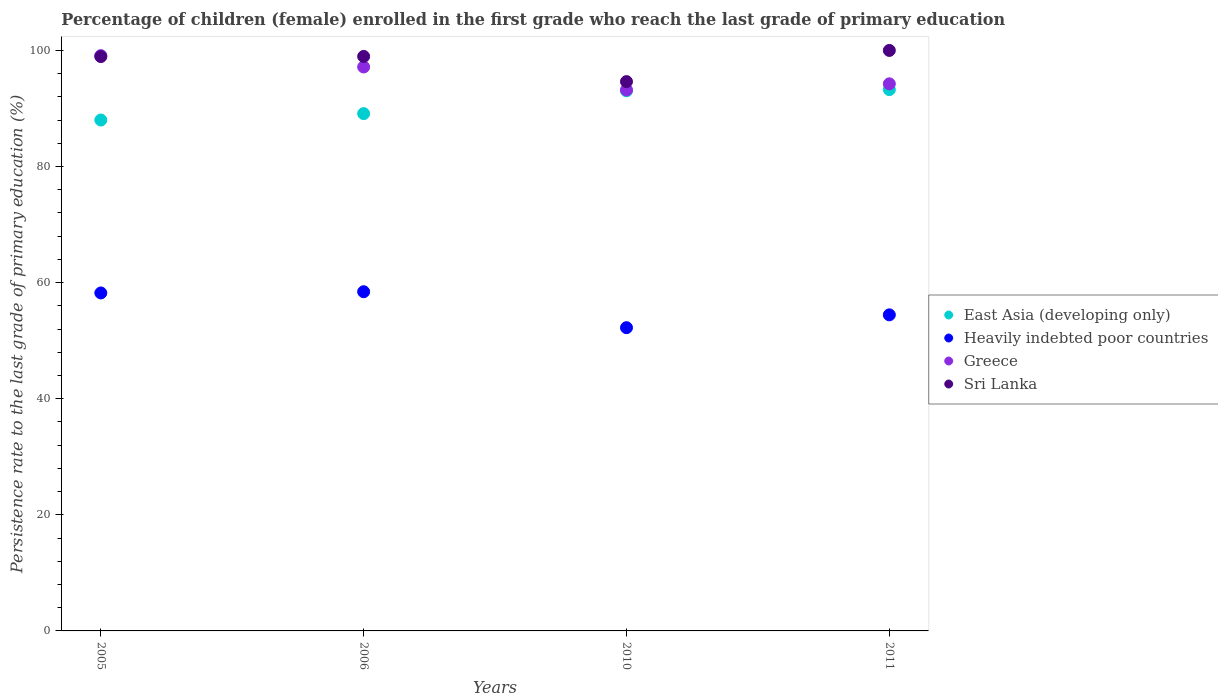Is the number of dotlines equal to the number of legend labels?
Provide a succinct answer. Yes. What is the persistence rate of children in Greece in 2005?
Ensure brevity in your answer.  99.1. Across all years, what is the maximum persistence rate of children in East Asia (developing only)?
Provide a succinct answer. 93.26. Across all years, what is the minimum persistence rate of children in Heavily indebted poor countries?
Your answer should be very brief. 52.24. In which year was the persistence rate of children in East Asia (developing only) minimum?
Provide a short and direct response. 2005. What is the total persistence rate of children in Sri Lanka in the graph?
Keep it short and to the point. 392.54. What is the difference between the persistence rate of children in Heavily indebted poor countries in 2005 and that in 2010?
Ensure brevity in your answer.  5.98. What is the difference between the persistence rate of children in Sri Lanka in 2006 and the persistence rate of children in Greece in 2005?
Offer a very short reply. -0.14. What is the average persistence rate of children in East Asia (developing only) per year?
Offer a very short reply. 90.86. In the year 2006, what is the difference between the persistence rate of children in East Asia (developing only) and persistence rate of children in Greece?
Offer a terse response. -8.04. What is the ratio of the persistence rate of children in Sri Lanka in 2010 to that in 2011?
Make the answer very short. 0.95. What is the difference between the highest and the second highest persistence rate of children in East Asia (developing only)?
Provide a succinct answer. 0.21. What is the difference between the highest and the lowest persistence rate of children in Greece?
Your response must be concise. 5.91. In how many years, is the persistence rate of children in East Asia (developing only) greater than the average persistence rate of children in East Asia (developing only) taken over all years?
Your answer should be very brief. 2. Is the sum of the persistence rate of children in Heavily indebted poor countries in 2005 and 2006 greater than the maximum persistence rate of children in Greece across all years?
Your answer should be very brief. Yes. Is it the case that in every year, the sum of the persistence rate of children in Greece and persistence rate of children in East Asia (developing only)  is greater than the sum of persistence rate of children in Sri Lanka and persistence rate of children in Heavily indebted poor countries?
Ensure brevity in your answer.  No. Is it the case that in every year, the sum of the persistence rate of children in Heavily indebted poor countries and persistence rate of children in Greece  is greater than the persistence rate of children in Sri Lanka?
Keep it short and to the point. Yes. Is the persistence rate of children in Greece strictly greater than the persistence rate of children in Sri Lanka over the years?
Give a very brief answer. No. How many dotlines are there?
Your answer should be very brief. 4. How many years are there in the graph?
Ensure brevity in your answer.  4. Does the graph contain any zero values?
Provide a short and direct response. No. How many legend labels are there?
Give a very brief answer. 4. What is the title of the graph?
Make the answer very short. Percentage of children (female) enrolled in the first grade who reach the last grade of primary education. Does "Belize" appear as one of the legend labels in the graph?
Your response must be concise. No. What is the label or title of the X-axis?
Your answer should be very brief. Years. What is the label or title of the Y-axis?
Make the answer very short. Persistence rate to the last grade of primary education (%). What is the Persistence rate to the last grade of primary education (%) in East Asia (developing only) in 2005?
Provide a succinct answer. 88.01. What is the Persistence rate to the last grade of primary education (%) in Heavily indebted poor countries in 2005?
Ensure brevity in your answer.  58.22. What is the Persistence rate to the last grade of primary education (%) of Greece in 2005?
Make the answer very short. 99.1. What is the Persistence rate to the last grade of primary education (%) in Sri Lanka in 2005?
Give a very brief answer. 98.94. What is the Persistence rate to the last grade of primary education (%) in East Asia (developing only) in 2006?
Provide a succinct answer. 89.12. What is the Persistence rate to the last grade of primary education (%) of Heavily indebted poor countries in 2006?
Make the answer very short. 58.43. What is the Persistence rate to the last grade of primary education (%) of Greece in 2006?
Your answer should be very brief. 97.15. What is the Persistence rate to the last grade of primary education (%) in Sri Lanka in 2006?
Ensure brevity in your answer.  98.97. What is the Persistence rate to the last grade of primary education (%) in East Asia (developing only) in 2010?
Your answer should be very brief. 93.05. What is the Persistence rate to the last grade of primary education (%) of Heavily indebted poor countries in 2010?
Give a very brief answer. 52.24. What is the Persistence rate to the last grade of primary education (%) of Greece in 2010?
Your answer should be very brief. 93.19. What is the Persistence rate to the last grade of primary education (%) in Sri Lanka in 2010?
Make the answer very short. 94.63. What is the Persistence rate to the last grade of primary education (%) in East Asia (developing only) in 2011?
Give a very brief answer. 93.26. What is the Persistence rate to the last grade of primary education (%) in Heavily indebted poor countries in 2011?
Provide a succinct answer. 54.45. What is the Persistence rate to the last grade of primary education (%) in Greece in 2011?
Offer a very short reply. 94.25. Across all years, what is the maximum Persistence rate to the last grade of primary education (%) of East Asia (developing only)?
Make the answer very short. 93.26. Across all years, what is the maximum Persistence rate to the last grade of primary education (%) of Heavily indebted poor countries?
Ensure brevity in your answer.  58.43. Across all years, what is the maximum Persistence rate to the last grade of primary education (%) in Greece?
Your answer should be very brief. 99.1. Across all years, what is the maximum Persistence rate to the last grade of primary education (%) in Sri Lanka?
Offer a terse response. 100. Across all years, what is the minimum Persistence rate to the last grade of primary education (%) in East Asia (developing only)?
Make the answer very short. 88.01. Across all years, what is the minimum Persistence rate to the last grade of primary education (%) of Heavily indebted poor countries?
Keep it short and to the point. 52.24. Across all years, what is the minimum Persistence rate to the last grade of primary education (%) of Greece?
Your answer should be compact. 93.19. Across all years, what is the minimum Persistence rate to the last grade of primary education (%) of Sri Lanka?
Offer a terse response. 94.63. What is the total Persistence rate to the last grade of primary education (%) in East Asia (developing only) in the graph?
Your response must be concise. 363.43. What is the total Persistence rate to the last grade of primary education (%) in Heavily indebted poor countries in the graph?
Your answer should be compact. 223.35. What is the total Persistence rate to the last grade of primary education (%) in Greece in the graph?
Offer a terse response. 383.7. What is the total Persistence rate to the last grade of primary education (%) of Sri Lanka in the graph?
Provide a short and direct response. 392.54. What is the difference between the Persistence rate to the last grade of primary education (%) in East Asia (developing only) in 2005 and that in 2006?
Ensure brevity in your answer.  -1.1. What is the difference between the Persistence rate to the last grade of primary education (%) in Heavily indebted poor countries in 2005 and that in 2006?
Provide a short and direct response. -0.21. What is the difference between the Persistence rate to the last grade of primary education (%) of Greece in 2005 and that in 2006?
Your response must be concise. 1.95. What is the difference between the Persistence rate to the last grade of primary education (%) of Sri Lanka in 2005 and that in 2006?
Your response must be concise. -0.02. What is the difference between the Persistence rate to the last grade of primary education (%) in East Asia (developing only) in 2005 and that in 2010?
Provide a short and direct response. -5.03. What is the difference between the Persistence rate to the last grade of primary education (%) in Heavily indebted poor countries in 2005 and that in 2010?
Provide a short and direct response. 5.98. What is the difference between the Persistence rate to the last grade of primary education (%) in Greece in 2005 and that in 2010?
Your answer should be compact. 5.91. What is the difference between the Persistence rate to the last grade of primary education (%) in Sri Lanka in 2005 and that in 2010?
Offer a terse response. 4.31. What is the difference between the Persistence rate to the last grade of primary education (%) in East Asia (developing only) in 2005 and that in 2011?
Your answer should be compact. -5.24. What is the difference between the Persistence rate to the last grade of primary education (%) of Heavily indebted poor countries in 2005 and that in 2011?
Offer a terse response. 3.77. What is the difference between the Persistence rate to the last grade of primary education (%) of Greece in 2005 and that in 2011?
Your answer should be compact. 4.85. What is the difference between the Persistence rate to the last grade of primary education (%) in Sri Lanka in 2005 and that in 2011?
Offer a very short reply. -1.06. What is the difference between the Persistence rate to the last grade of primary education (%) in East Asia (developing only) in 2006 and that in 2010?
Keep it short and to the point. -3.93. What is the difference between the Persistence rate to the last grade of primary education (%) in Heavily indebted poor countries in 2006 and that in 2010?
Offer a very short reply. 6.19. What is the difference between the Persistence rate to the last grade of primary education (%) in Greece in 2006 and that in 2010?
Keep it short and to the point. 3.96. What is the difference between the Persistence rate to the last grade of primary education (%) in Sri Lanka in 2006 and that in 2010?
Make the answer very short. 4.34. What is the difference between the Persistence rate to the last grade of primary education (%) of East Asia (developing only) in 2006 and that in 2011?
Offer a very short reply. -4.14. What is the difference between the Persistence rate to the last grade of primary education (%) of Heavily indebted poor countries in 2006 and that in 2011?
Ensure brevity in your answer.  3.98. What is the difference between the Persistence rate to the last grade of primary education (%) in Greece in 2006 and that in 2011?
Keep it short and to the point. 2.9. What is the difference between the Persistence rate to the last grade of primary education (%) in Sri Lanka in 2006 and that in 2011?
Provide a short and direct response. -1.03. What is the difference between the Persistence rate to the last grade of primary education (%) of East Asia (developing only) in 2010 and that in 2011?
Offer a very short reply. -0.21. What is the difference between the Persistence rate to the last grade of primary education (%) of Heavily indebted poor countries in 2010 and that in 2011?
Keep it short and to the point. -2.21. What is the difference between the Persistence rate to the last grade of primary education (%) in Greece in 2010 and that in 2011?
Your response must be concise. -1.05. What is the difference between the Persistence rate to the last grade of primary education (%) in Sri Lanka in 2010 and that in 2011?
Your answer should be very brief. -5.37. What is the difference between the Persistence rate to the last grade of primary education (%) in East Asia (developing only) in 2005 and the Persistence rate to the last grade of primary education (%) in Heavily indebted poor countries in 2006?
Make the answer very short. 29.58. What is the difference between the Persistence rate to the last grade of primary education (%) of East Asia (developing only) in 2005 and the Persistence rate to the last grade of primary education (%) of Greece in 2006?
Make the answer very short. -9.14. What is the difference between the Persistence rate to the last grade of primary education (%) of East Asia (developing only) in 2005 and the Persistence rate to the last grade of primary education (%) of Sri Lanka in 2006?
Give a very brief answer. -10.95. What is the difference between the Persistence rate to the last grade of primary education (%) in Heavily indebted poor countries in 2005 and the Persistence rate to the last grade of primary education (%) in Greece in 2006?
Keep it short and to the point. -38.93. What is the difference between the Persistence rate to the last grade of primary education (%) of Heavily indebted poor countries in 2005 and the Persistence rate to the last grade of primary education (%) of Sri Lanka in 2006?
Your answer should be very brief. -40.74. What is the difference between the Persistence rate to the last grade of primary education (%) in Greece in 2005 and the Persistence rate to the last grade of primary education (%) in Sri Lanka in 2006?
Give a very brief answer. 0.14. What is the difference between the Persistence rate to the last grade of primary education (%) of East Asia (developing only) in 2005 and the Persistence rate to the last grade of primary education (%) of Heavily indebted poor countries in 2010?
Ensure brevity in your answer.  35.77. What is the difference between the Persistence rate to the last grade of primary education (%) in East Asia (developing only) in 2005 and the Persistence rate to the last grade of primary education (%) in Greece in 2010?
Make the answer very short. -5.18. What is the difference between the Persistence rate to the last grade of primary education (%) in East Asia (developing only) in 2005 and the Persistence rate to the last grade of primary education (%) in Sri Lanka in 2010?
Your answer should be very brief. -6.62. What is the difference between the Persistence rate to the last grade of primary education (%) of Heavily indebted poor countries in 2005 and the Persistence rate to the last grade of primary education (%) of Greece in 2010?
Ensure brevity in your answer.  -34.97. What is the difference between the Persistence rate to the last grade of primary education (%) of Heavily indebted poor countries in 2005 and the Persistence rate to the last grade of primary education (%) of Sri Lanka in 2010?
Your response must be concise. -36.41. What is the difference between the Persistence rate to the last grade of primary education (%) of Greece in 2005 and the Persistence rate to the last grade of primary education (%) of Sri Lanka in 2010?
Your answer should be very brief. 4.47. What is the difference between the Persistence rate to the last grade of primary education (%) of East Asia (developing only) in 2005 and the Persistence rate to the last grade of primary education (%) of Heavily indebted poor countries in 2011?
Give a very brief answer. 33.56. What is the difference between the Persistence rate to the last grade of primary education (%) of East Asia (developing only) in 2005 and the Persistence rate to the last grade of primary education (%) of Greece in 2011?
Make the answer very short. -6.24. What is the difference between the Persistence rate to the last grade of primary education (%) in East Asia (developing only) in 2005 and the Persistence rate to the last grade of primary education (%) in Sri Lanka in 2011?
Make the answer very short. -11.99. What is the difference between the Persistence rate to the last grade of primary education (%) of Heavily indebted poor countries in 2005 and the Persistence rate to the last grade of primary education (%) of Greece in 2011?
Make the answer very short. -36.03. What is the difference between the Persistence rate to the last grade of primary education (%) in Heavily indebted poor countries in 2005 and the Persistence rate to the last grade of primary education (%) in Sri Lanka in 2011?
Your response must be concise. -41.78. What is the difference between the Persistence rate to the last grade of primary education (%) in Greece in 2005 and the Persistence rate to the last grade of primary education (%) in Sri Lanka in 2011?
Give a very brief answer. -0.9. What is the difference between the Persistence rate to the last grade of primary education (%) in East Asia (developing only) in 2006 and the Persistence rate to the last grade of primary education (%) in Heavily indebted poor countries in 2010?
Your answer should be very brief. 36.88. What is the difference between the Persistence rate to the last grade of primary education (%) of East Asia (developing only) in 2006 and the Persistence rate to the last grade of primary education (%) of Greece in 2010?
Ensure brevity in your answer.  -4.08. What is the difference between the Persistence rate to the last grade of primary education (%) of East Asia (developing only) in 2006 and the Persistence rate to the last grade of primary education (%) of Sri Lanka in 2010?
Provide a succinct answer. -5.51. What is the difference between the Persistence rate to the last grade of primary education (%) in Heavily indebted poor countries in 2006 and the Persistence rate to the last grade of primary education (%) in Greece in 2010?
Your answer should be compact. -34.76. What is the difference between the Persistence rate to the last grade of primary education (%) of Heavily indebted poor countries in 2006 and the Persistence rate to the last grade of primary education (%) of Sri Lanka in 2010?
Your answer should be very brief. -36.2. What is the difference between the Persistence rate to the last grade of primary education (%) of Greece in 2006 and the Persistence rate to the last grade of primary education (%) of Sri Lanka in 2010?
Give a very brief answer. 2.52. What is the difference between the Persistence rate to the last grade of primary education (%) in East Asia (developing only) in 2006 and the Persistence rate to the last grade of primary education (%) in Heavily indebted poor countries in 2011?
Provide a short and direct response. 34.67. What is the difference between the Persistence rate to the last grade of primary education (%) of East Asia (developing only) in 2006 and the Persistence rate to the last grade of primary education (%) of Greece in 2011?
Offer a terse response. -5.13. What is the difference between the Persistence rate to the last grade of primary education (%) in East Asia (developing only) in 2006 and the Persistence rate to the last grade of primary education (%) in Sri Lanka in 2011?
Your response must be concise. -10.88. What is the difference between the Persistence rate to the last grade of primary education (%) of Heavily indebted poor countries in 2006 and the Persistence rate to the last grade of primary education (%) of Greece in 2011?
Provide a succinct answer. -35.82. What is the difference between the Persistence rate to the last grade of primary education (%) in Heavily indebted poor countries in 2006 and the Persistence rate to the last grade of primary education (%) in Sri Lanka in 2011?
Ensure brevity in your answer.  -41.57. What is the difference between the Persistence rate to the last grade of primary education (%) of Greece in 2006 and the Persistence rate to the last grade of primary education (%) of Sri Lanka in 2011?
Your response must be concise. -2.85. What is the difference between the Persistence rate to the last grade of primary education (%) in East Asia (developing only) in 2010 and the Persistence rate to the last grade of primary education (%) in Heavily indebted poor countries in 2011?
Keep it short and to the point. 38.6. What is the difference between the Persistence rate to the last grade of primary education (%) in East Asia (developing only) in 2010 and the Persistence rate to the last grade of primary education (%) in Greece in 2011?
Keep it short and to the point. -1.2. What is the difference between the Persistence rate to the last grade of primary education (%) of East Asia (developing only) in 2010 and the Persistence rate to the last grade of primary education (%) of Sri Lanka in 2011?
Provide a succinct answer. -6.95. What is the difference between the Persistence rate to the last grade of primary education (%) in Heavily indebted poor countries in 2010 and the Persistence rate to the last grade of primary education (%) in Greece in 2011?
Give a very brief answer. -42.01. What is the difference between the Persistence rate to the last grade of primary education (%) of Heavily indebted poor countries in 2010 and the Persistence rate to the last grade of primary education (%) of Sri Lanka in 2011?
Your answer should be compact. -47.76. What is the difference between the Persistence rate to the last grade of primary education (%) of Greece in 2010 and the Persistence rate to the last grade of primary education (%) of Sri Lanka in 2011?
Give a very brief answer. -6.81. What is the average Persistence rate to the last grade of primary education (%) of East Asia (developing only) per year?
Offer a terse response. 90.86. What is the average Persistence rate to the last grade of primary education (%) of Heavily indebted poor countries per year?
Your response must be concise. 55.84. What is the average Persistence rate to the last grade of primary education (%) of Greece per year?
Ensure brevity in your answer.  95.92. What is the average Persistence rate to the last grade of primary education (%) of Sri Lanka per year?
Your answer should be very brief. 98.14. In the year 2005, what is the difference between the Persistence rate to the last grade of primary education (%) in East Asia (developing only) and Persistence rate to the last grade of primary education (%) in Heavily indebted poor countries?
Make the answer very short. 29.79. In the year 2005, what is the difference between the Persistence rate to the last grade of primary education (%) of East Asia (developing only) and Persistence rate to the last grade of primary education (%) of Greece?
Offer a terse response. -11.09. In the year 2005, what is the difference between the Persistence rate to the last grade of primary education (%) of East Asia (developing only) and Persistence rate to the last grade of primary education (%) of Sri Lanka?
Make the answer very short. -10.93. In the year 2005, what is the difference between the Persistence rate to the last grade of primary education (%) of Heavily indebted poor countries and Persistence rate to the last grade of primary education (%) of Greece?
Make the answer very short. -40.88. In the year 2005, what is the difference between the Persistence rate to the last grade of primary education (%) in Heavily indebted poor countries and Persistence rate to the last grade of primary education (%) in Sri Lanka?
Make the answer very short. -40.72. In the year 2005, what is the difference between the Persistence rate to the last grade of primary education (%) in Greece and Persistence rate to the last grade of primary education (%) in Sri Lanka?
Offer a very short reply. 0.16. In the year 2006, what is the difference between the Persistence rate to the last grade of primary education (%) of East Asia (developing only) and Persistence rate to the last grade of primary education (%) of Heavily indebted poor countries?
Your answer should be very brief. 30.68. In the year 2006, what is the difference between the Persistence rate to the last grade of primary education (%) in East Asia (developing only) and Persistence rate to the last grade of primary education (%) in Greece?
Give a very brief answer. -8.04. In the year 2006, what is the difference between the Persistence rate to the last grade of primary education (%) in East Asia (developing only) and Persistence rate to the last grade of primary education (%) in Sri Lanka?
Make the answer very short. -9.85. In the year 2006, what is the difference between the Persistence rate to the last grade of primary education (%) of Heavily indebted poor countries and Persistence rate to the last grade of primary education (%) of Greece?
Your answer should be very brief. -38.72. In the year 2006, what is the difference between the Persistence rate to the last grade of primary education (%) in Heavily indebted poor countries and Persistence rate to the last grade of primary education (%) in Sri Lanka?
Give a very brief answer. -40.53. In the year 2006, what is the difference between the Persistence rate to the last grade of primary education (%) of Greece and Persistence rate to the last grade of primary education (%) of Sri Lanka?
Your response must be concise. -1.82. In the year 2010, what is the difference between the Persistence rate to the last grade of primary education (%) of East Asia (developing only) and Persistence rate to the last grade of primary education (%) of Heavily indebted poor countries?
Provide a succinct answer. 40.81. In the year 2010, what is the difference between the Persistence rate to the last grade of primary education (%) of East Asia (developing only) and Persistence rate to the last grade of primary education (%) of Greece?
Keep it short and to the point. -0.15. In the year 2010, what is the difference between the Persistence rate to the last grade of primary education (%) of East Asia (developing only) and Persistence rate to the last grade of primary education (%) of Sri Lanka?
Provide a succinct answer. -1.58. In the year 2010, what is the difference between the Persistence rate to the last grade of primary education (%) of Heavily indebted poor countries and Persistence rate to the last grade of primary education (%) of Greece?
Provide a succinct answer. -40.95. In the year 2010, what is the difference between the Persistence rate to the last grade of primary education (%) of Heavily indebted poor countries and Persistence rate to the last grade of primary education (%) of Sri Lanka?
Offer a very short reply. -42.39. In the year 2010, what is the difference between the Persistence rate to the last grade of primary education (%) in Greece and Persistence rate to the last grade of primary education (%) in Sri Lanka?
Offer a terse response. -1.44. In the year 2011, what is the difference between the Persistence rate to the last grade of primary education (%) in East Asia (developing only) and Persistence rate to the last grade of primary education (%) in Heavily indebted poor countries?
Keep it short and to the point. 38.81. In the year 2011, what is the difference between the Persistence rate to the last grade of primary education (%) in East Asia (developing only) and Persistence rate to the last grade of primary education (%) in Greece?
Your answer should be compact. -0.99. In the year 2011, what is the difference between the Persistence rate to the last grade of primary education (%) in East Asia (developing only) and Persistence rate to the last grade of primary education (%) in Sri Lanka?
Provide a short and direct response. -6.74. In the year 2011, what is the difference between the Persistence rate to the last grade of primary education (%) in Heavily indebted poor countries and Persistence rate to the last grade of primary education (%) in Greece?
Make the answer very short. -39.8. In the year 2011, what is the difference between the Persistence rate to the last grade of primary education (%) in Heavily indebted poor countries and Persistence rate to the last grade of primary education (%) in Sri Lanka?
Ensure brevity in your answer.  -45.55. In the year 2011, what is the difference between the Persistence rate to the last grade of primary education (%) in Greece and Persistence rate to the last grade of primary education (%) in Sri Lanka?
Offer a terse response. -5.75. What is the ratio of the Persistence rate to the last grade of primary education (%) of East Asia (developing only) in 2005 to that in 2006?
Keep it short and to the point. 0.99. What is the ratio of the Persistence rate to the last grade of primary education (%) of Greece in 2005 to that in 2006?
Offer a terse response. 1.02. What is the ratio of the Persistence rate to the last grade of primary education (%) of East Asia (developing only) in 2005 to that in 2010?
Your response must be concise. 0.95. What is the ratio of the Persistence rate to the last grade of primary education (%) of Heavily indebted poor countries in 2005 to that in 2010?
Offer a very short reply. 1.11. What is the ratio of the Persistence rate to the last grade of primary education (%) of Greece in 2005 to that in 2010?
Offer a terse response. 1.06. What is the ratio of the Persistence rate to the last grade of primary education (%) of Sri Lanka in 2005 to that in 2010?
Keep it short and to the point. 1.05. What is the ratio of the Persistence rate to the last grade of primary education (%) of East Asia (developing only) in 2005 to that in 2011?
Offer a terse response. 0.94. What is the ratio of the Persistence rate to the last grade of primary education (%) in Heavily indebted poor countries in 2005 to that in 2011?
Provide a succinct answer. 1.07. What is the ratio of the Persistence rate to the last grade of primary education (%) of Greece in 2005 to that in 2011?
Offer a very short reply. 1.05. What is the ratio of the Persistence rate to the last grade of primary education (%) in East Asia (developing only) in 2006 to that in 2010?
Offer a terse response. 0.96. What is the ratio of the Persistence rate to the last grade of primary education (%) of Heavily indebted poor countries in 2006 to that in 2010?
Give a very brief answer. 1.12. What is the ratio of the Persistence rate to the last grade of primary education (%) in Greece in 2006 to that in 2010?
Make the answer very short. 1.04. What is the ratio of the Persistence rate to the last grade of primary education (%) of Sri Lanka in 2006 to that in 2010?
Your answer should be very brief. 1.05. What is the ratio of the Persistence rate to the last grade of primary education (%) in East Asia (developing only) in 2006 to that in 2011?
Your response must be concise. 0.96. What is the ratio of the Persistence rate to the last grade of primary education (%) of Heavily indebted poor countries in 2006 to that in 2011?
Make the answer very short. 1.07. What is the ratio of the Persistence rate to the last grade of primary education (%) of Greece in 2006 to that in 2011?
Ensure brevity in your answer.  1.03. What is the ratio of the Persistence rate to the last grade of primary education (%) of Sri Lanka in 2006 to that in 2011?
Your response must be concise. 0.99. What is the ratio of the Persistence rate to the last grade of primary education (%) of East Asia (developing only) in 2010 to that in 2011?
Ensure brevity in your answer.  1. What is the ratio of the Persistence rate to the last grade of primary education (%) of Heavily indebted poor countries in 2010 to that in 2011?
Your response must be concise. 0.96. What is the ratio of the Persistence rate to the last grade of primary education (%) of Greece in 2010 to that in 2011?
Your response must be concise. 0.99. What is the ratio of the Persistence rate to the last grade of primary education (%) in Sri Lanka in 2010 to that in 2011?
Give a very brief answer. 0.95. What is the difference between the highest and the second highest Persistence rate to the last grade of primary education (%) in East Asia (developing only)?
Give a very brief answer. 0.21. What is the difference between the highest and the second highest Persistence rate to the last grade of primary education (%) in Heavily indebted poor countries?
Provide a short and direct response. 0.21. What is the difference between the highest and the second highest Persistence rate to the last grade of primary education (%) in Greece?
Offer a terse response. 1.95. What is the difference between the highest and the second highest Persistence rate to the last grade of primary education (%) of Sri Lanka?
Your answer should be compact. 1.03. What is the difference between the highest and the lowest Persistence rate to the last grade of primary education (%) of East Asia (developing only)?
Keep it short and to the point. 5.24. What is the difference between the highest and the lowest Persistence rate to the last grade of primary education (%) of Heavily indebted poor countries?
Provide a short and direct response. 6.19. What is the difference between the highest and the lowest Persistence rate to the last grade of primary education (%) in Greece?
Your answer should be very brief. 5.91. What is the difference between the highest and the lowest Persistence rate to the last grade of primary education (%) of Sri Lanka?
Give a very brief answer. 5.37. 